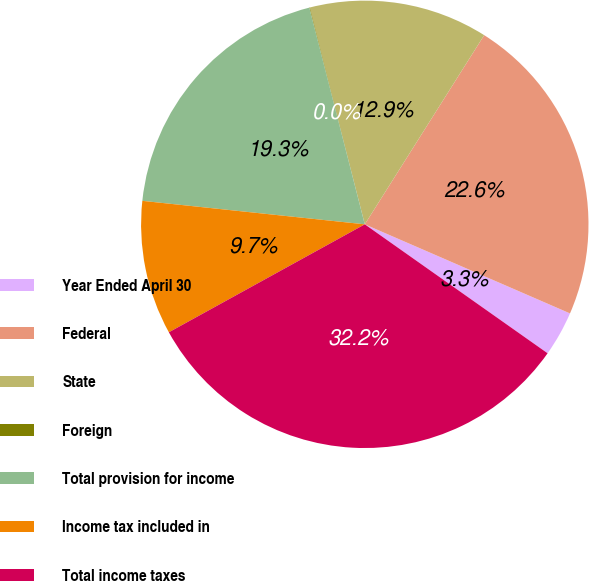<chart> <loc_0><loc_0><loc_500><loc_500><pie_chart><fcel>Year Ended April 30<fcel>Federal<fcel>State<fcel>Foreign<fcel>Total provision for income<fcel>Income tax included in<fcel>Total income taxes<nl><fcel>3.26%<fcel>22.56%<fcel>12.91%<fcel>0.04%<fcel>19.34%<fcel>9.69%<fcel>32.21%<nl></chart> 